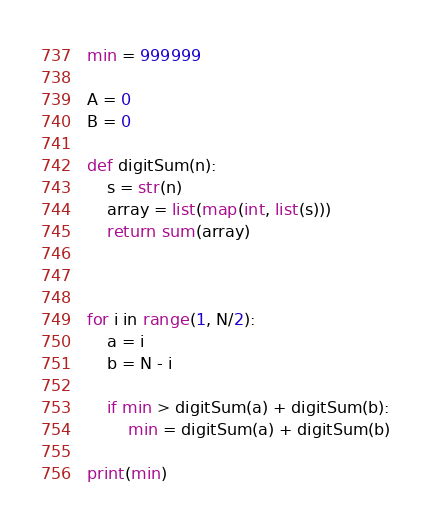<code> <loc_0><loc_0><loc_500><loc_500><_Python_>min = 999999

A = 0
B = 0

def digitSum(n):
    s = str(n)
    array = list(map(int, list(s)))
    return sum(array)



for i in range(1, N/2):
    a = i
    b = N - i

    if min > digitSum(a) + digitSum(b):
        min = digitSum(a) + digitSum(b)   

print(min)</code> 